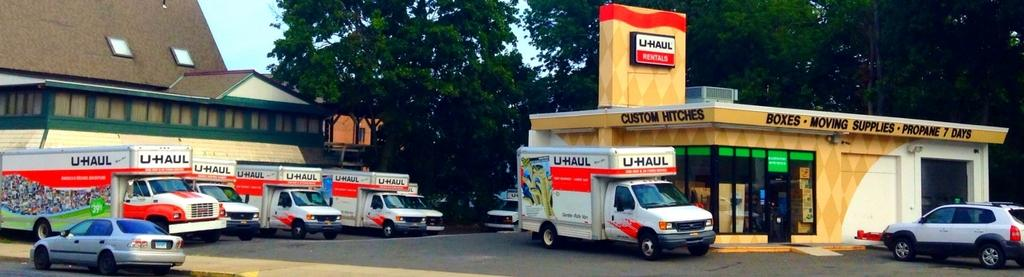What can be seen on the road in the image? There are vehicles on the road in the image. What type of structures are present in the image? There are buildings in the image. What objects are displayed on the boards in the image? The information about the boards is not provided, so we cannot determine what objects are displayed on them. What type of vegetation is present in the image? There are trees in the image. What is visible in the background of the image? The sky is visible in the background of the image. What type of quartz can be seen on the vehicles in the image? There is no quartz present on the vehicles in the image. Can you tell me how many teeth are visible on the buildings in the image? There are no teeth visible on the buildings in the image. 